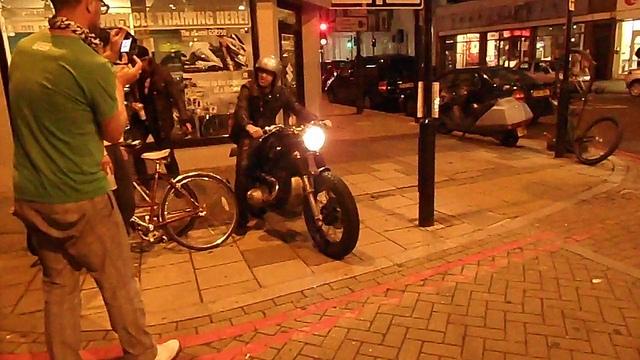Is the cell phone on?
Quick response, please. Yes. What does it say on the store window?
Be succinct. Motorcycle training here. How many lights are on the front of the motorcycle?
Give a very brief answer. 1. 